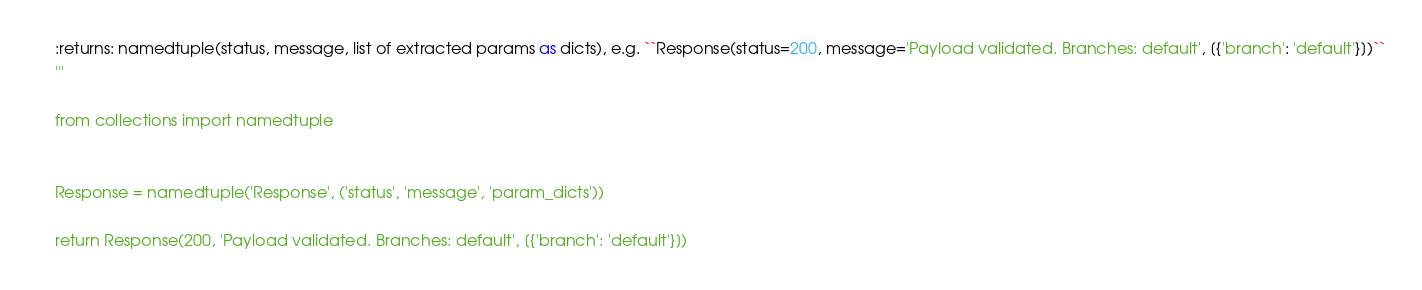<code> <loc_0><loc_0><loc_500><loc_500><_Python_>    :returns: namedtuple(status, message, list of extracted params as dicts), e.g. ``Response(status=200, message='Payload validated. Branches: default', [{'branch': 'default'}])``
    '''

    from collections import namedtuple


    Response = namedtuple('Response', ('status', 'message', 'param_dicts'))

    return Response(200, 'Payload validated. Branches: default', [{'branch': 'default'}])

</code> 